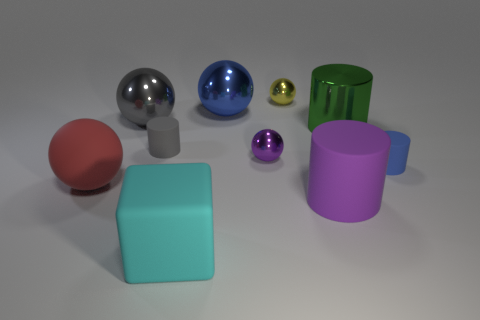Subtract all large blue metallic spheres. How many spheres are left? 4 Subtract all blue spheres. How many spheres are left? 4 Subtract all green spheres. Subtract all cyan blocks. How many spheres are left? 5 Subtract all cylinders. How many objects are left? 6 Subtract all big metal things. Subtract all big blue objects. How many objects are left? 6 Add 6 big blocks. How many big blocks are left? 7 Add 6 big red objects. How many big red objects exist? 7 Subtract 1 purple cylinders. How many objects are left? 9 